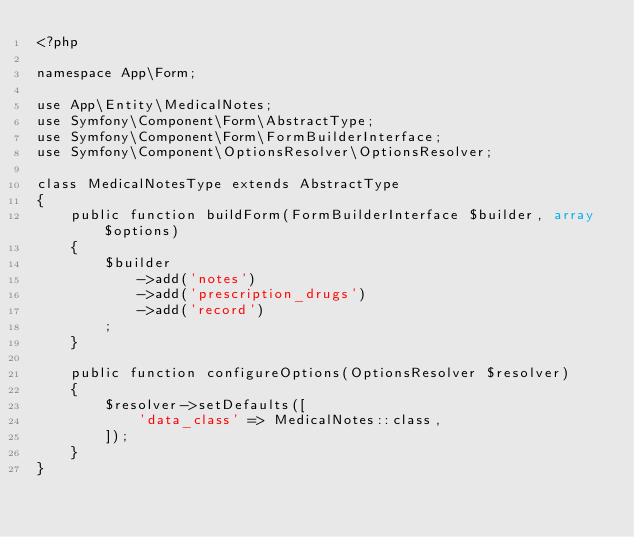<code> <loc_0><loc_0><loc_500><loc_500><_PHP_><?php

namespace App\Form;

use App\Entity\MedicalNotes;
use Symfony\Component\Form\AbstractType;
use Symfony\Component\Form\FormBuilderInterface;
use Symfony\Component\OptionsResolver\OptionsResolver;

class MedicalNotesType extends AbstractType
{
    public function buildForm(FormBuilderInterface $builder, array $options)
    {
        $builder
            ->add('notes')
            ->add('prescription_drugs')
            ->add('record')
        ;
    }

    public function configureOptions(OptionsResolver $resolver)
    {
        $resolver->setDefaults([
            'data_class' => MedicalNotes::class,
        ]);
    }
}
</code> 